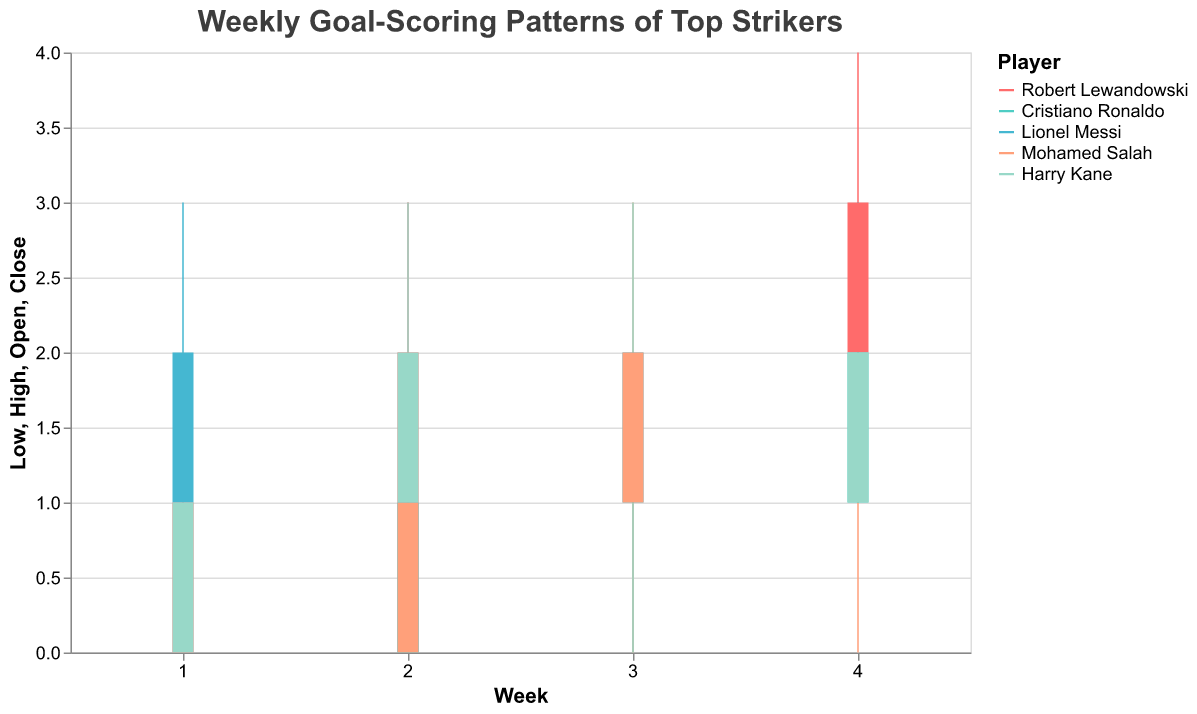Which player had the highest goal in any single week? By examining the 'High' value for each player across all weeks, we see that Robert Lewandowski had the highest number with a value of 4 in Week 4.
Answer: Robert Lewandowski In Week 2, did any players have the same 'Close' values? Looking at Week 2 for each player, Robert Lewandowski, Cristiano Ronaldo, Lionel Messi, Mohamed Salah, and Harry Kane all have different 'Close' values of 2, 1, 1, 1, 2 respectively.
Answer: No What was the total number of goals scored by Mohamed Salah by the 'Close' values across all weeks? Sum the 'Close' values for Mohamed Salah: 0 (Week 1) + 1 (Week 2) + 2 (Week 3) + 1 (Week 4) = 4 goals.
Answer: 4 Which week saw the highest average 'High' value among all players? Calculate the average 'High' for each week: Week 1 (2+1+3+1+2)/5 = 1.8, Week 2 (3+2+1+2+3)/5 = 2.2, Week 3 (2+2+2+3+3)/5 = 2.4, Week 4 (4+3+3+2+2)/5 = 2.8. The highest average occurs in Week 4.
Answer: Week 4 Did Lionel Messi have any weeks where his 'Open' and 'Close' values were the same? Look at all weeks for Lionel Messi: Week 1 (1, 2), Week 2 (0, 1), Week 3 (1, 2), Week 4 (2, 2). In Week 4, both values are 2.
Answer: Yes How many total goals were scored by Harry Kane in Weeks 1 and 2 based on the 'Close' values? Add Harry Kane's 'Close' values for Weeks 1 and 2: 1 (Week 1) + 2 (Week 2) = 3 goals.
Answer: 3 Which player showed the most stable or least variable performance in terms of 'High' values? To determine stability, look for the player whose 'High' values change the least across weeks. Cristiano Ronaldo's values are: 1, 2, 2, 3 which are less variable compared to other players.
Answer: Cristiano Ronaldo Is there any week where the 'High' value was the same for all players? Checking each week, none of the 'High' values are identical for all players in any week.
Answer: No Which player consistently had a higher 'Close' value than 'Open' value across all four weeks? Compare 'Open' and 'Close' for all four weeks for each player. Robert Lewandowski: 0<1, 1<2, 1=1, 2<3; Cristiano Ronaldo: 0=0, 0<1, 1=1, 1<2; Lionel Messi: 1<2, 0<1, 1=2, 2=2; Mohamed Salah: 0=0, 0<1, 1<2, 1=1; Harry Kane: 0<1, 1<2, 2=2, 1=2. Robert Lewandowski consistently has a higher 'Close' than 'Open' in all four weeks.
Answer: Robert Lewandowski 